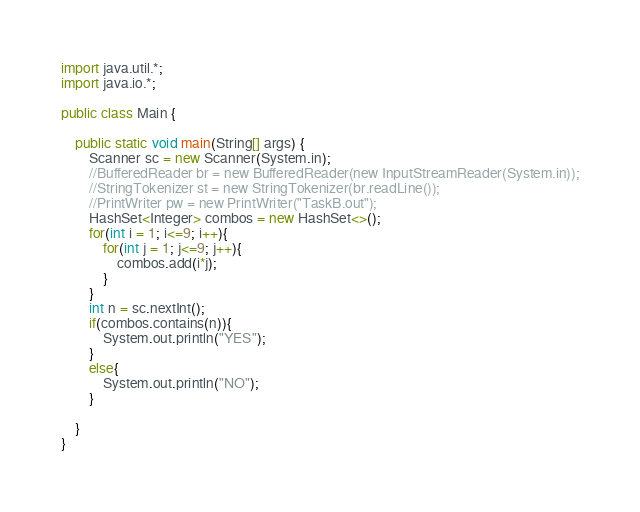<code> <loc_0><loc_0><loc_500><loc_500><_Java_>import java.util.*;
import java.io.*;

public class Main {

    public static void main(String[] args) {
        Scanner sc = new Scanner(System.in);
        //BufferedReader br = new BufferedReader(new InputStreamReader(System.in));
        //StringTokenizer st = new StringTokenizer(br.readLine());
        //PrintWriter pw = new PrintWriter("TaskB.out");
        HashSet<Integer> combos = new HashSet<>();
        for(int i = 1; i<=9; i++){
            for(int j = 1; j<=9; j++){
                combos.add(i*j);
            }
        }
        int n = sc.nextInt();
        if(combos.contains(n)){
            System.out.println("YES");
        }
        else{
            System.out.println("NO");
        }

    }
}</code> 